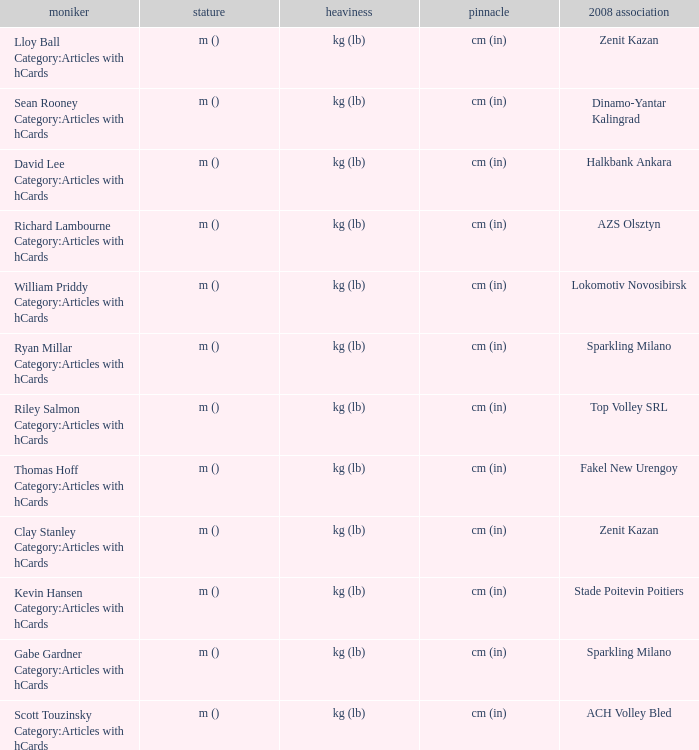What is the name for the 2008 club of Azs olsztyn? Richard Lambourne Category:Articles with hCards. 